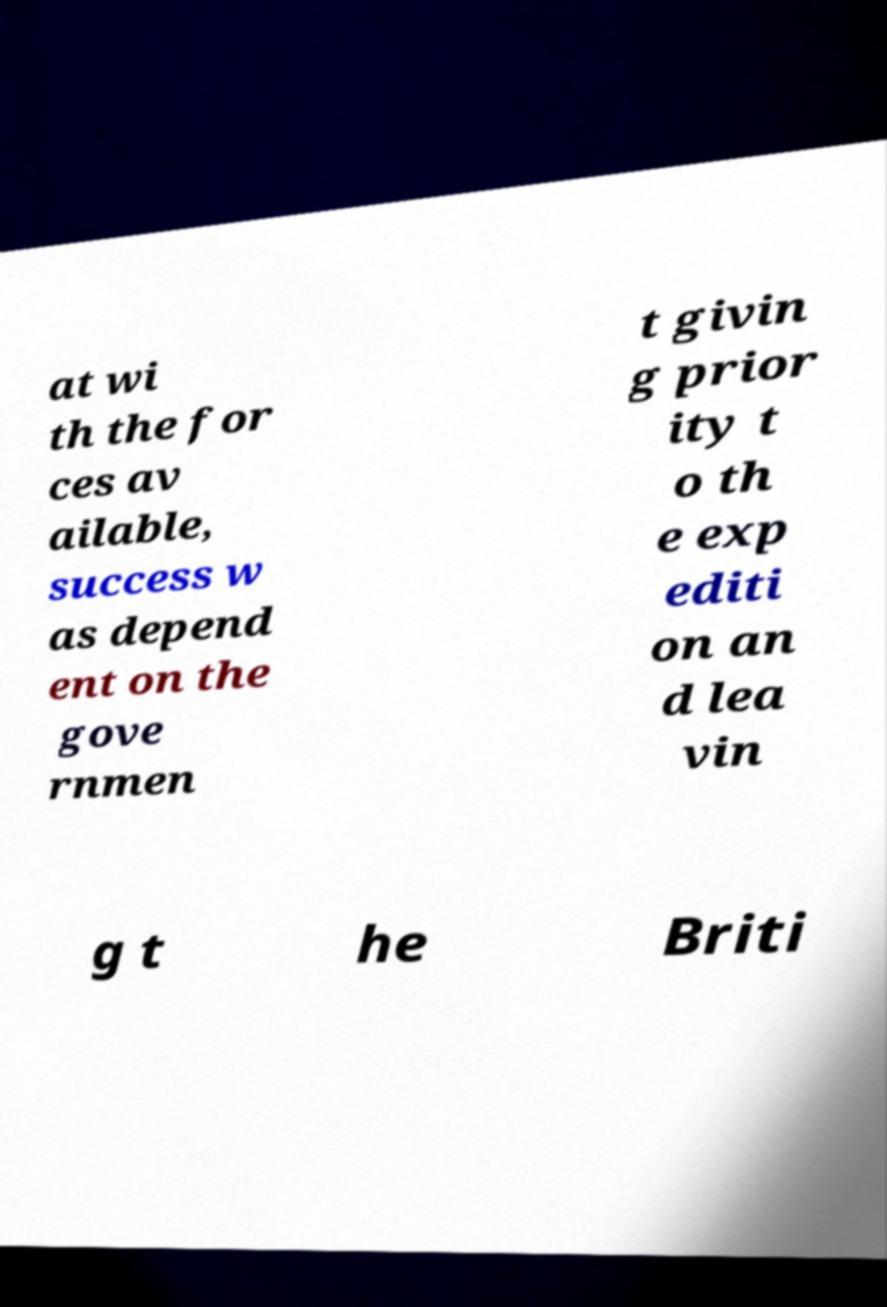Please identify and transcribe the text found in this image. at wi th the for ces av ailable, success w as depend ent on the gove rnmen t givin g prior ity t o th e exp editi on an d lea vin g t he Briti 